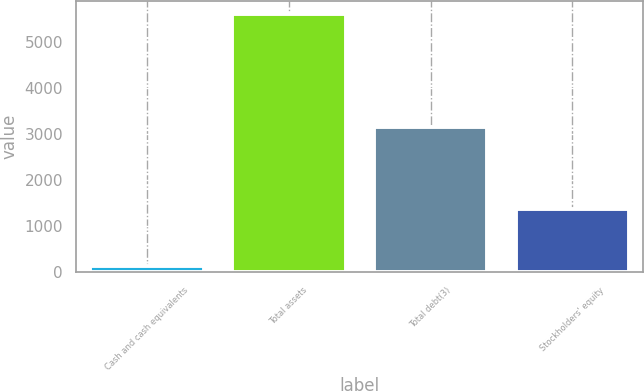Convert chart. <chart><loc_0><loc_0><loc_500><loc_500><bar_chart><fcel>Cash and cash equivalents<fcel>Total assets<fcel>Total debt(3)<fcel>Stockholders' equity<nl><fcel>138.3<fcel>5593.7<fcel>3145.7<fcel>1372<nl></chart> 